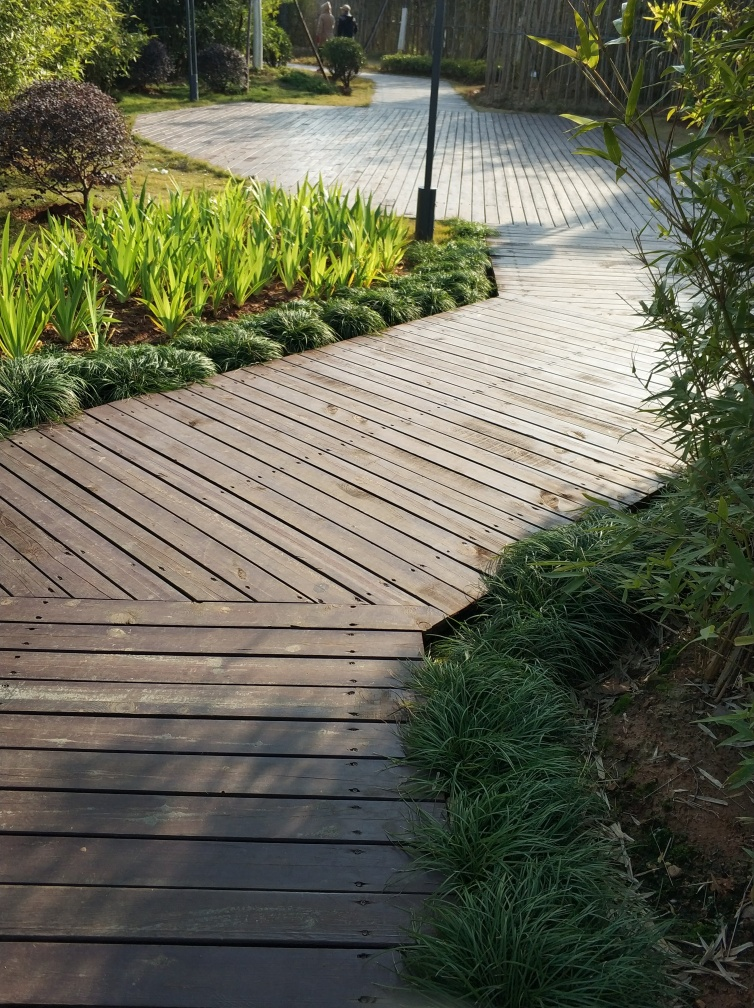Could you infer the kind of location or setting this pathway is in? The pathway appears to be in a public park or a similar recreational area, judging by the well-maintained landscaping, the presence of a lamp post, and what looks like a paved area in the distance, which may cater to pedestrians. The design and care suggest that it's a place meant for leisurely walks and enjoying nature. 